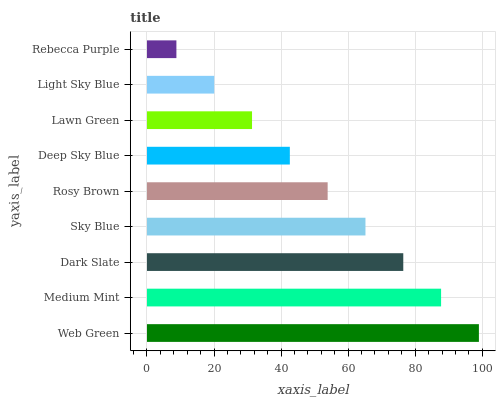Is Rebecca Purple the minimum?
Answer yes or no. Yes. Is Web Green the maximum?
Answer yes or no. Yes. Is Medium Mint the minimum?
Answer yes or no. No. Is Medium Mint the maximum?
Answer yes or no. No. Is Web Green greater than Medium Mint?
Answer yes or no. Yes. Is Medium Mint less than Web Green?
Answer yes or no. Yes. Is Medium Mint greater than Web Green?
Answer yes or no. No. Is Web Green less than Medium Mint?
Answer yes or no. No. Is Rosy Brown the high median?
Answer yes or no. Yes. Is Rosy Brown the low median?
Answer yes or no. Yes. Is Deep Sky Blue the high median?
Answer yes or no. No. Is Sky Blue the low median?
Answer yes or no. No. 